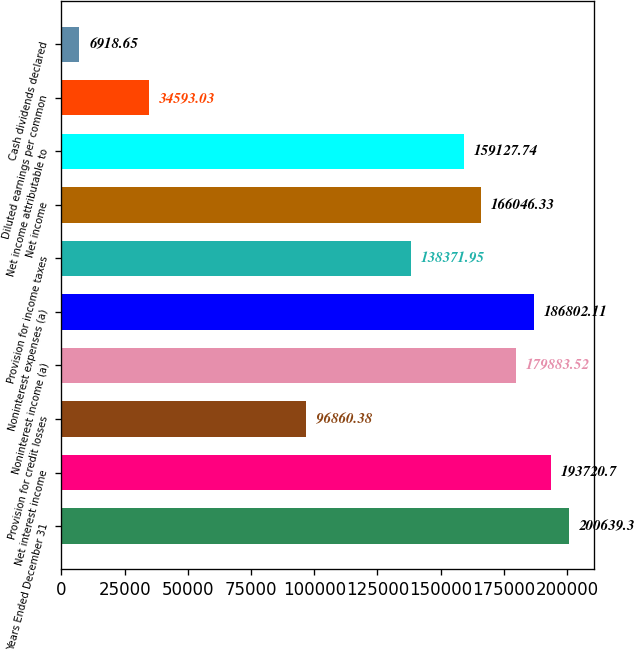Convert chart. <chart><loc_0><loc_0><loc_500><loc_500><bar_chart><fcel>Years Ended December 31<fcel>Net interest income<fcel>Provision for credit losses<fcel>Noninterest income (a)<fcel>Noninterest expenses (a)<fcel>Provision for income taxes<fcel>Net income<fcel>Net income attributable to<fcel>Diluted earnings per common<fcel>Cash dividends declared<nl><fcel>200639<fcel>193721<fcel>96860.4<fcel>179884<fcel>186802<fcel>138372<fcel>166046<fcel>159128<fcel>34593<fcel>6918.65<nl></chart> 